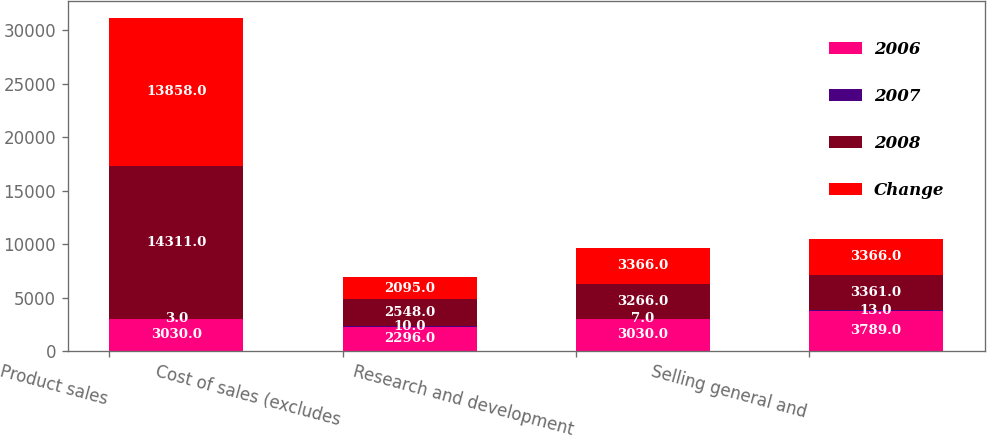<chart> <loc_0><loc_0><loc_500><loc_500><stacked_bar_chart><ecel><fcel>Product sales<fcel>Cost of sales (excludes<fcel>Research and development<fcel>Selling general and<nl><fcel>2006<fcel>3030<fcel>2296<fcel>3030<fcel>3789<nl><fcel>2007<fcel>3<fcel>10<fcel>7<fcel>13<nl><fcel>2008<fcel>14311<fcel>2548<fcel>3266<fcel>3361<nl><fcel>Change<fcel>13858<fcel>2095<fcel>3366<fcel>3366<nl></chart> 